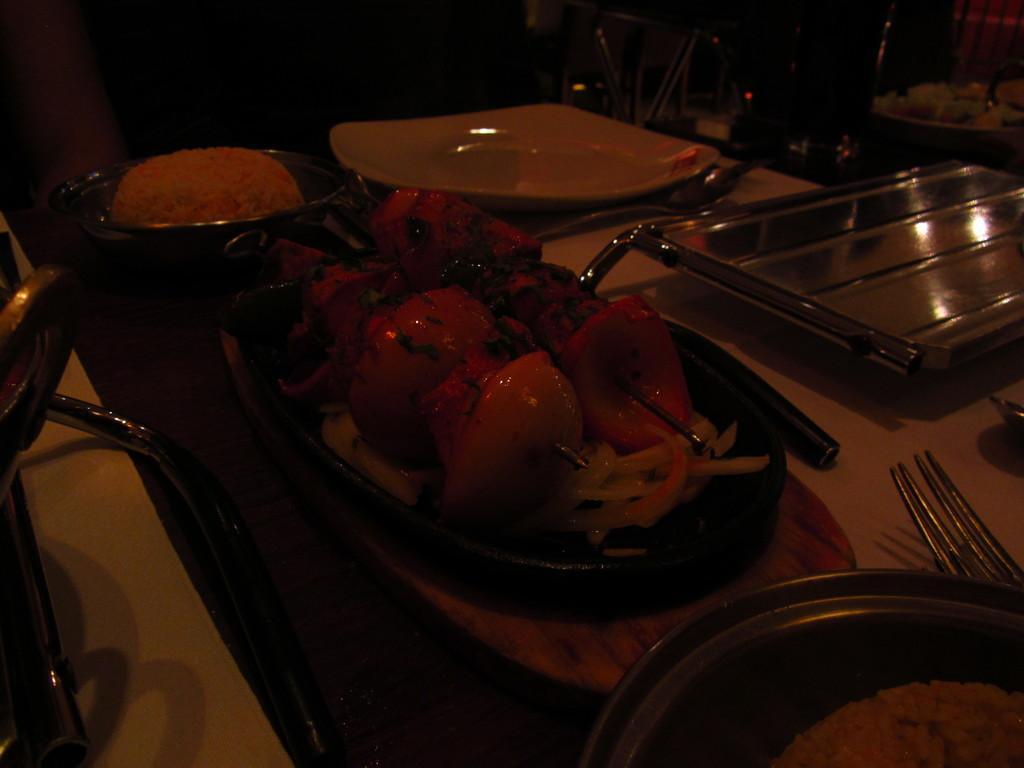How would you summarize this image in a sentence or two? In this image there are food items in the bowls and on the plate, and in the background there is a silver tray, plate, spoon, fork on the table. 